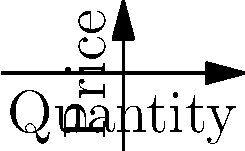In the graph, the demand curve shifts from Demand 1 to Demand 2. How does this shift affect the equilibrium price and quantity? What economic factors might cause such a shift in the context of recruiting economics graduates? To analyze the effect of the demand shift on equilibrium:

1. Initial equilibrium (E₁):
   - Occurs at the intersection of Supply and Demand 1
   - Price ≈ $7, Quantity ≈ 6

2. New equilibrium (E₂):
   - Occurs at the intersection of Supply and Demand 2
   - Price ≈ $6, Quantity ≈ 8

3. Effect of the shift:
   - Equilibrium price decreases
   - Equilibrium quantity increases

4. Economic interpretation:
   - The rightward shift of the demand curve indicates an increase in demand
   - This could be due to factors such as:
     a) Increased need for economic analysis in consulting firms
     b) Growing complexity of economic issues in business
     c) Expansion of the consulting industry

5. Recruiting context:
   - Higher demand for economics graduates
   - Potentially more competitive job market for employers
   - Possible need for improved compensation or benefits to attract candidates

The shift demonstrates the importance of understanding market dynamics in recruitment, as changes in demand can affect the strategies needed to attract qualified candidates.
Answer: Equilibrium price decreases, quantity increases. Factors: increased need for economic analysis, industry growth, market complexity. 